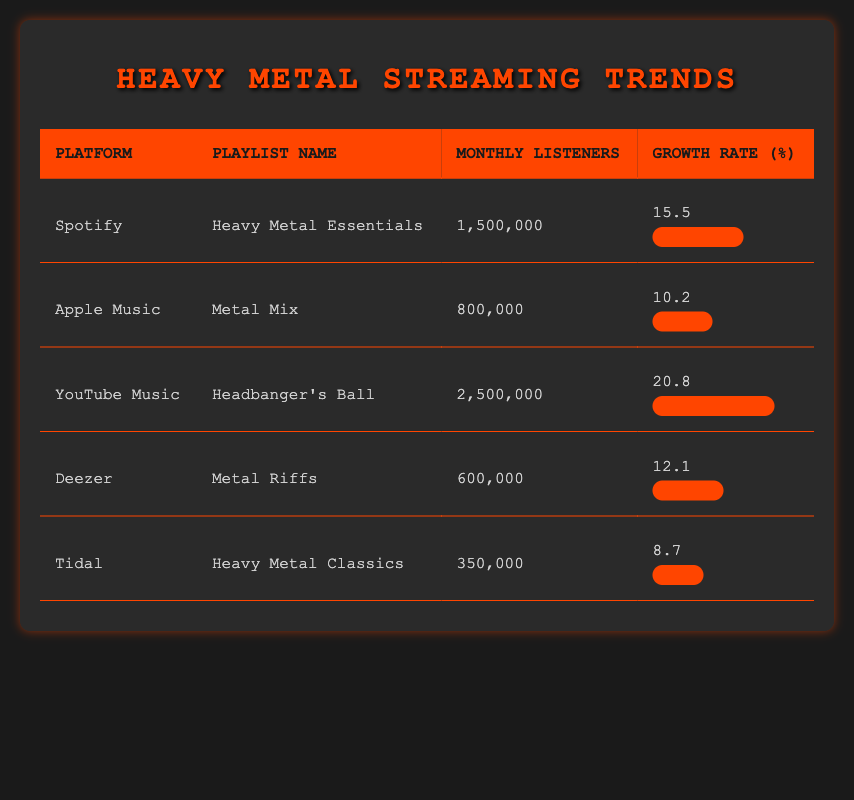What is the platform with the highest monthly listeners? From the table, YouTube Music has the highest number of monthly listeners at 2,500,000.
Answer: YouTube Music What is the growth rate of the "Heavy Metal Essentials" playlist on Spotify? The table indicates that the growth rate for the "Heavy Metal Essentials" playlist on Spotify is 15.5%.
Answer: 15.5% Which playlist has the lowest streaming growth rate? The "Heavy Metal Classics" playlist on Tidal has the lowest streaming growth rate, which is 8.7%.
Answer: Heavy Metal Classics What is the average number of monthly listeners across all platforms? To find the average, we add up the monthly listeners: 1,500,000 + 800,000 + 2,500,000 + 600,000 + 350,000 = 5,750,000. There are 5 platforms, so the average is 5,750,000 / 5 = 1,150,000.
Answer: 1,150,000 Is the growth rate of "Metal Mix" on Apple Music greater than that of "Metal Riffs" on Deezer? The growth rate of "Metal Mix" is 10.2%, and the growth rate of "Metal Riffs" is 12.1%. Since 10.2% is less than 12.1%, the statement is false.
Answer: No Which playlist has more monthly listeners: "Heavy Metal Essentials" or "Metal Riffs"? "Heavy Metal Essentials" has 1,500,000 monthly listeners, while "Metal Riffs" has 600,000. Since 1,500,000 is greater than 600,000, "Heavy Metal Essentials" has more monthly listeners.
Answer: Heavy Metal Essentials What is the total number of monthly listeners across all playlists? To find the total, add up each of the monthly listeners: 1,500,000 + 800,000 + 2,500,000 + 600,000 + 350,000 = 5,750,000.
Answer: 5,750,000 Which platform offers the "Headbanger's Ball" playlist? The table shows that "Headbanger's Ball" playlist is available on YouTube Music.
Answer: YouTube Music Is the monthly listener count of "Heavy Metal Classics" greater than 400,000? According to the table, "Heavy Metal Classics" has 350,000 monthly listeners, which is less than 400,000. Therefore, the statement is false.
Answer: No 